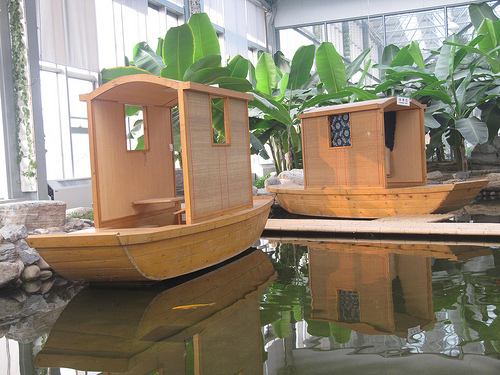<image>
Is the boat behind the boat? No. The boat is not behind the boat. From this viewpoint, the boat appears to be positioned elsewhere in the scene. Is there a trees in the water? No. The trees is not contained within the water. These objects have a different spatial relationship. 